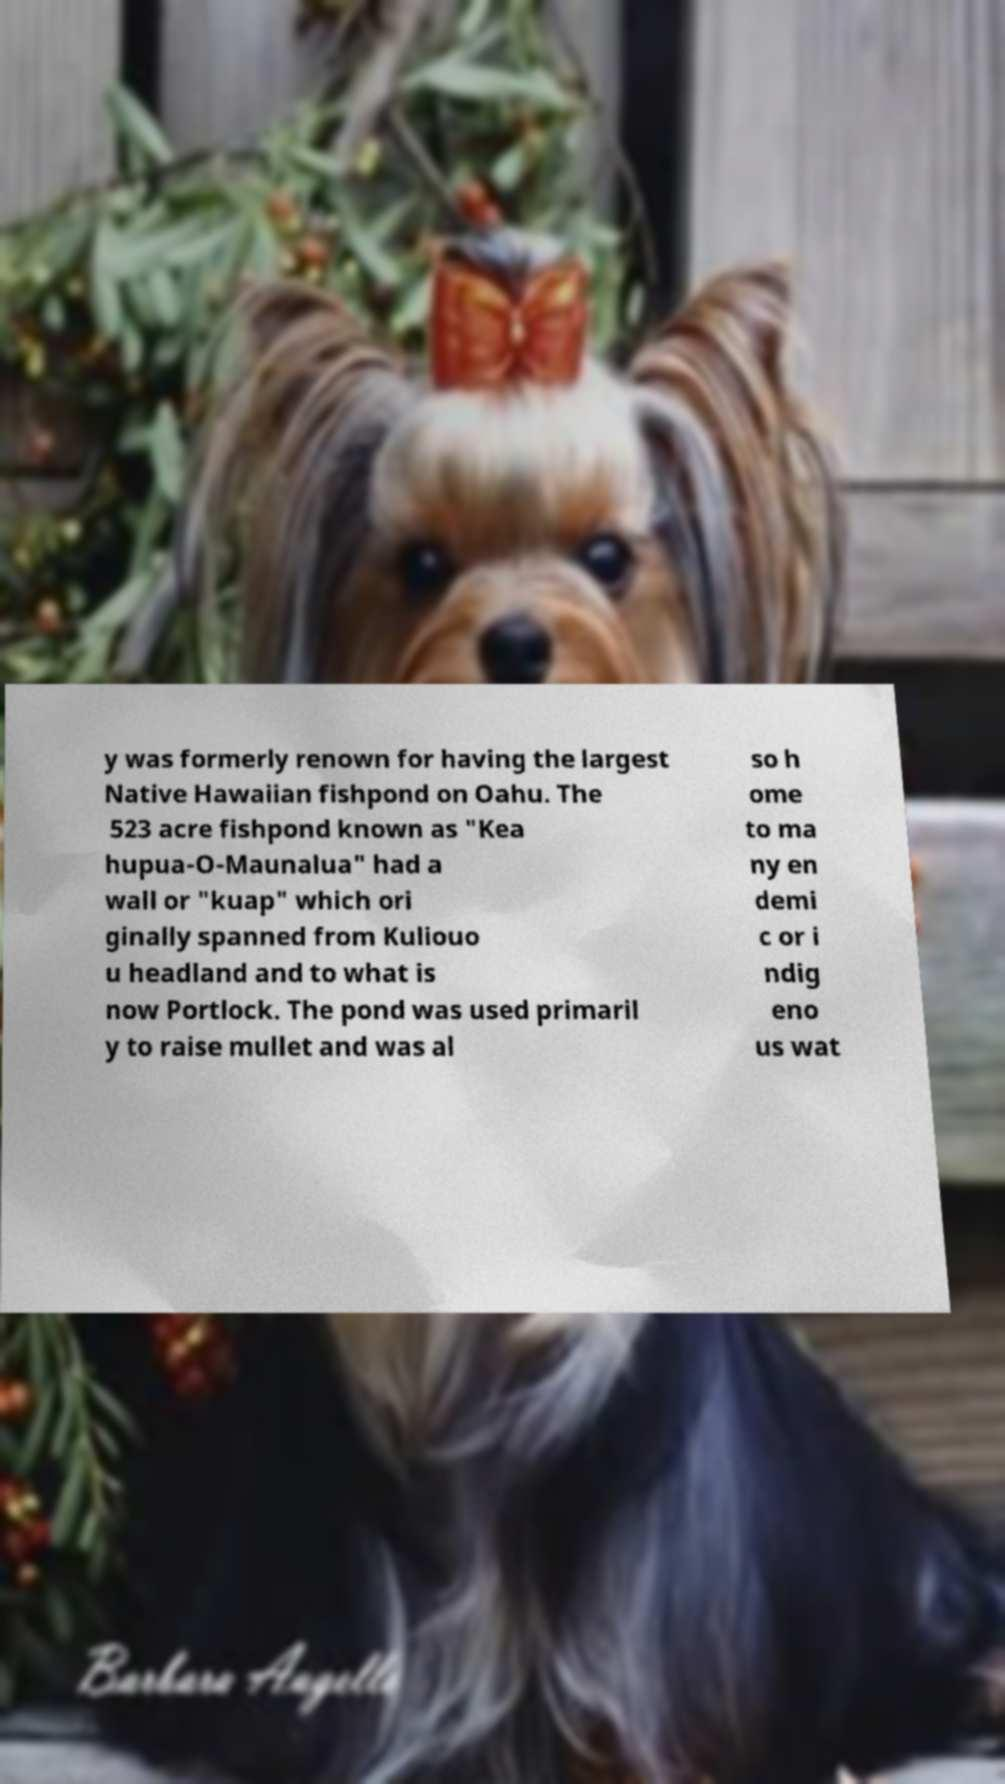For documentation purposes, I need the text within this image transcribed. Could you provide that? y was formerly renown for having the largest Native Hawaiian fishpond on Oahu. The 523 acre fishpond known as "Kea hupua-O-Maunalua" had a wall or "kuap" which ori ginally spanned from Kuliouo u headland and to what is now Portlock. The pond was used primaril y to raise mullet and was al so h ome to ma ny en demi c or i ndig eno us wat 